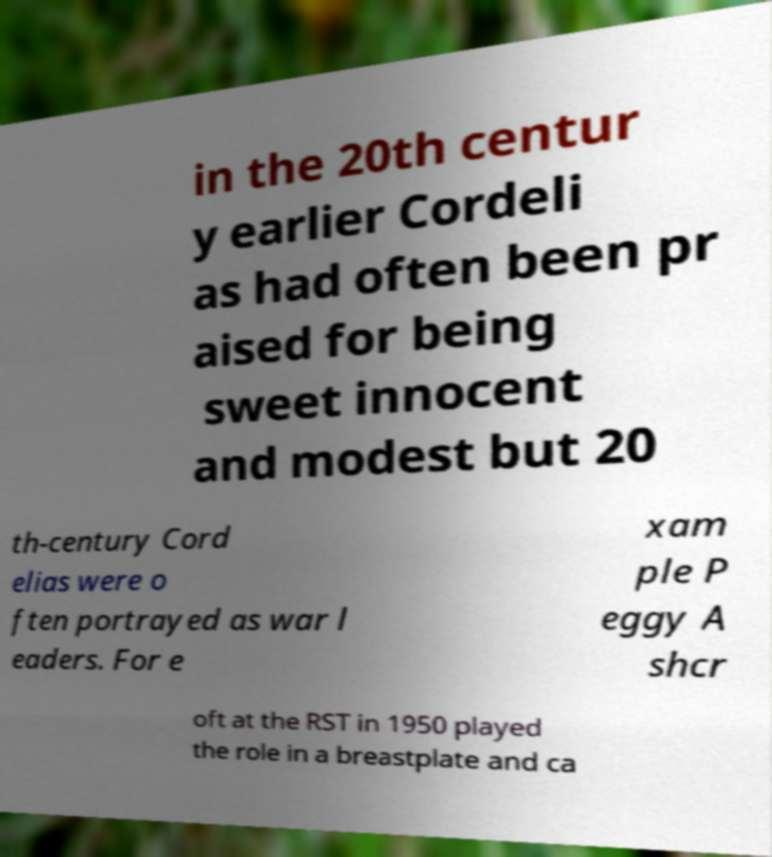Please identify and transcribe the text found in this image. in the 20th centur y earlier Cordeli as had often been pr aised for being sweet innocent and modest but 20 th-century Cord elias were o ften portrayed as war l eaders. For e xam ple P eggy A shcr oft at the RST in 1950 played the role in a breastplate and ca 